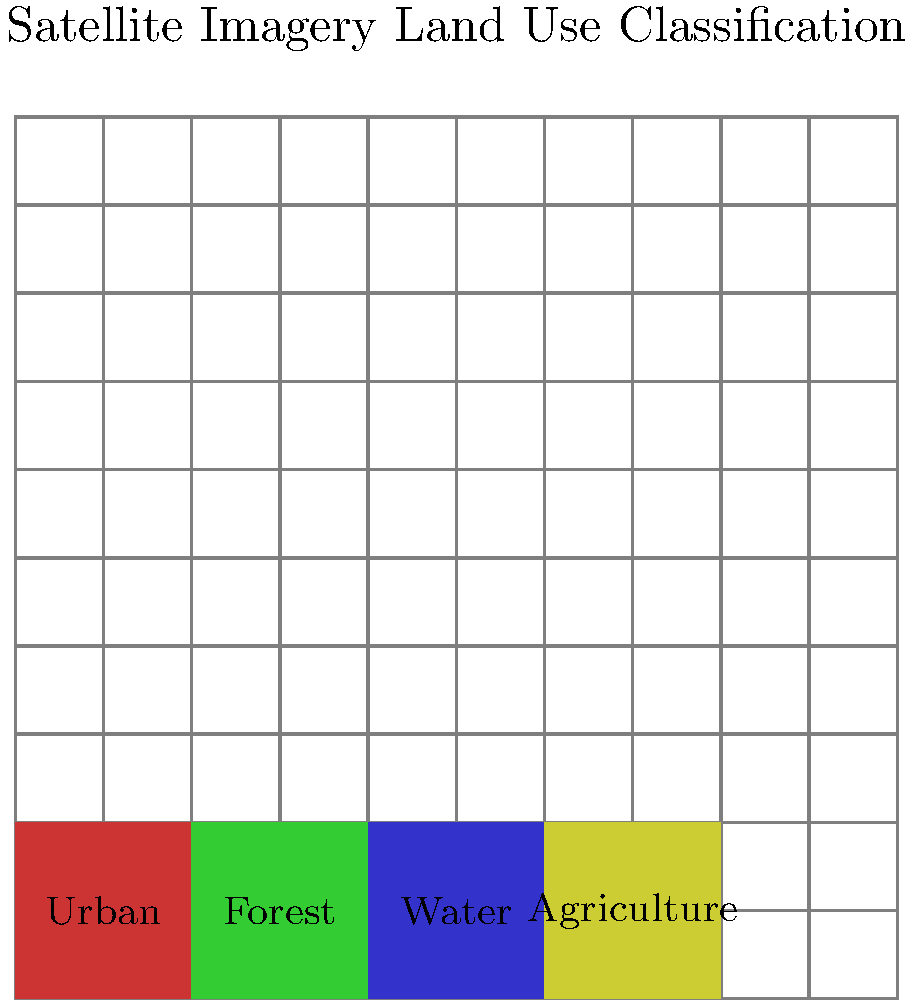In the satellite imagery above, which land use classification has the highest near-infrared (NIR) reflectance and why? Consider the spectral signatures of different land cover types. To answer this question, we need to consider the spectral signatures of different land cover types in the near-infrared (NIR) region:

1. Urban areas: Generally have low NIR reflectance due to the presence of built materials like concrete and asphalt, which absorb NIR radiation.

2. Forest: Has high NIR reflectance due to the internal structure of healthy vegetation leaves, which scatter NIR radiation.

3. Water: Absorbs most NIR radiation, resulting in very low reflectance.

4. Agriculture: Similar to forests, agricultural areas with healthy vegetation have high NIR reflectance.

Comparing these land cover types:

- Forest and agriculture both have high NIR reflectance due to vegetation.
- Urban areas have lower NIR reflectance than vegetation.
- Water has the lowest NIR reflectance among these types.

Between forest and agriculture, forest typically has slightly higher NIR reflectance due to the more complex canopy structure and higher leaf area index.

Therefore, the land use classification with the highest near-infrared (NIR) reflectance is forest.
Answer: Forest, due to its complex canopy structure and high leaf area index scattering NIR radiation. 